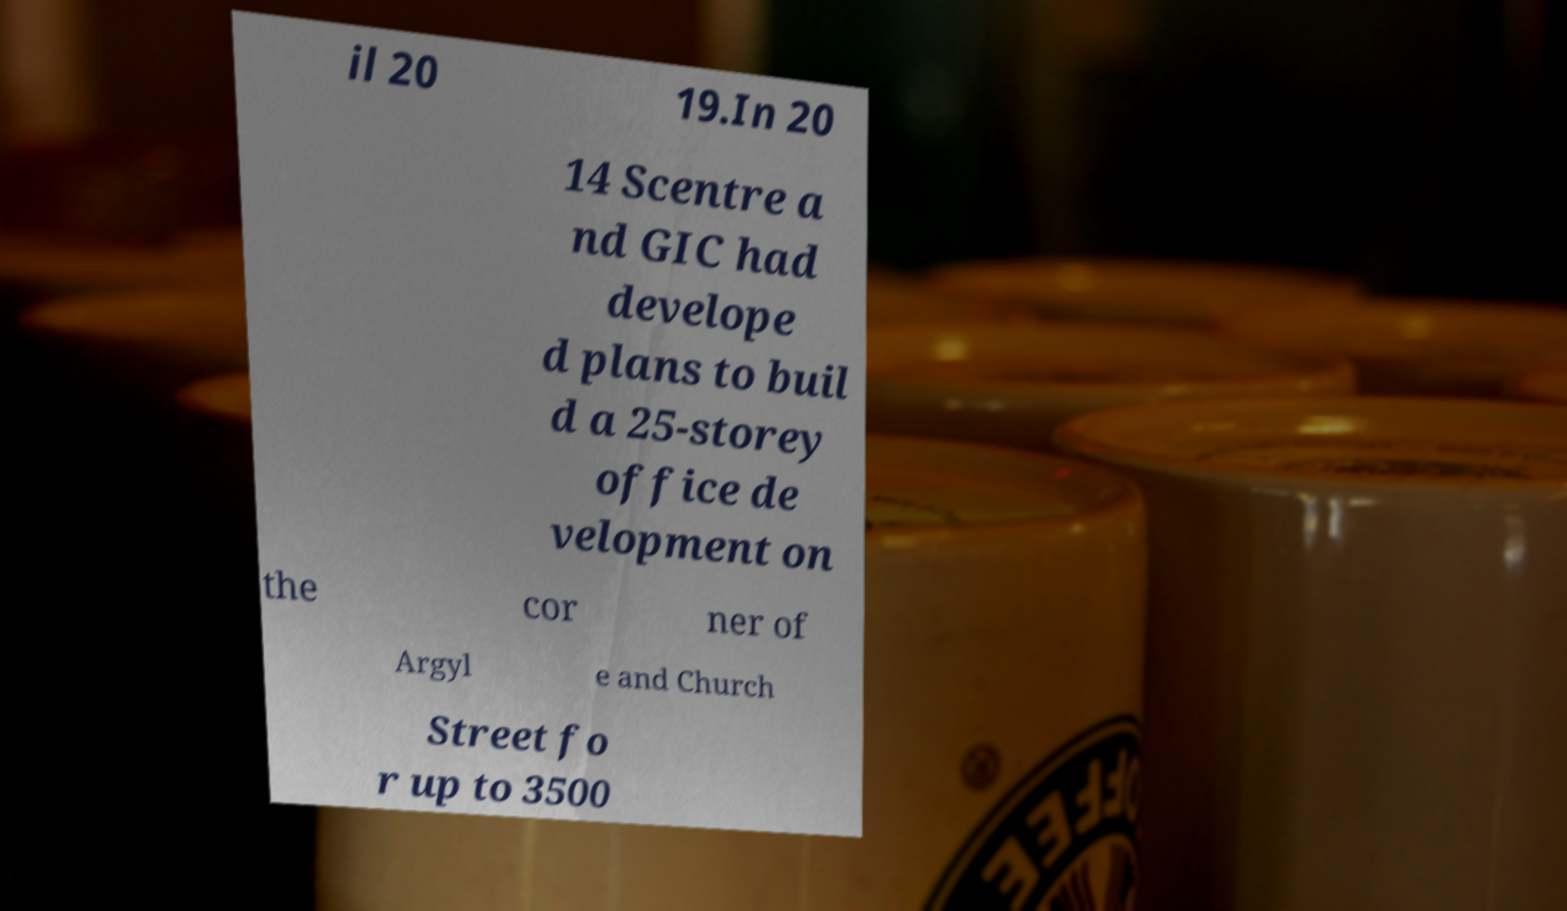Can you accurately transcribe the text from the provided image for me? il 20 19.In 20 14 Scentre a nd GIC had develope d plans to buil d a 25-storey office de velopment on the cor ner of Argyl e and Church Street fo r up to 3500 